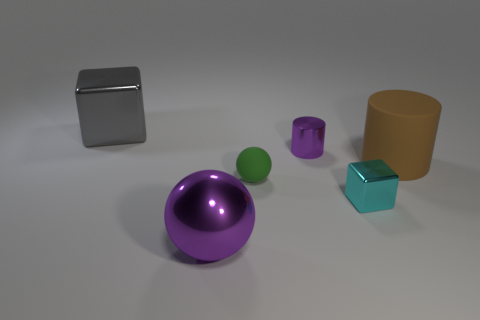Subtract all cyan blocks. How many blocks are left? 1 Add 4 tiny things. How many objects exist? 10 Subtract 0 green blocks. How many objects are left? 6 Subtract 1 cylinders. How many cylinders are left? 1 Subtract all brown cubes. Subtract all cyan cylinders. How many cubes are left? 2 Subtract all brown balls. How many cyan blocks are left? 1 Subtract all small blue rubber cubes. Subtract all big brown matte objects. How many objects are left? 5 Add 6 big cylinders. How many big cylinders are left? 7 Add 4 large shiny things. How many large shiny things exist? 6 